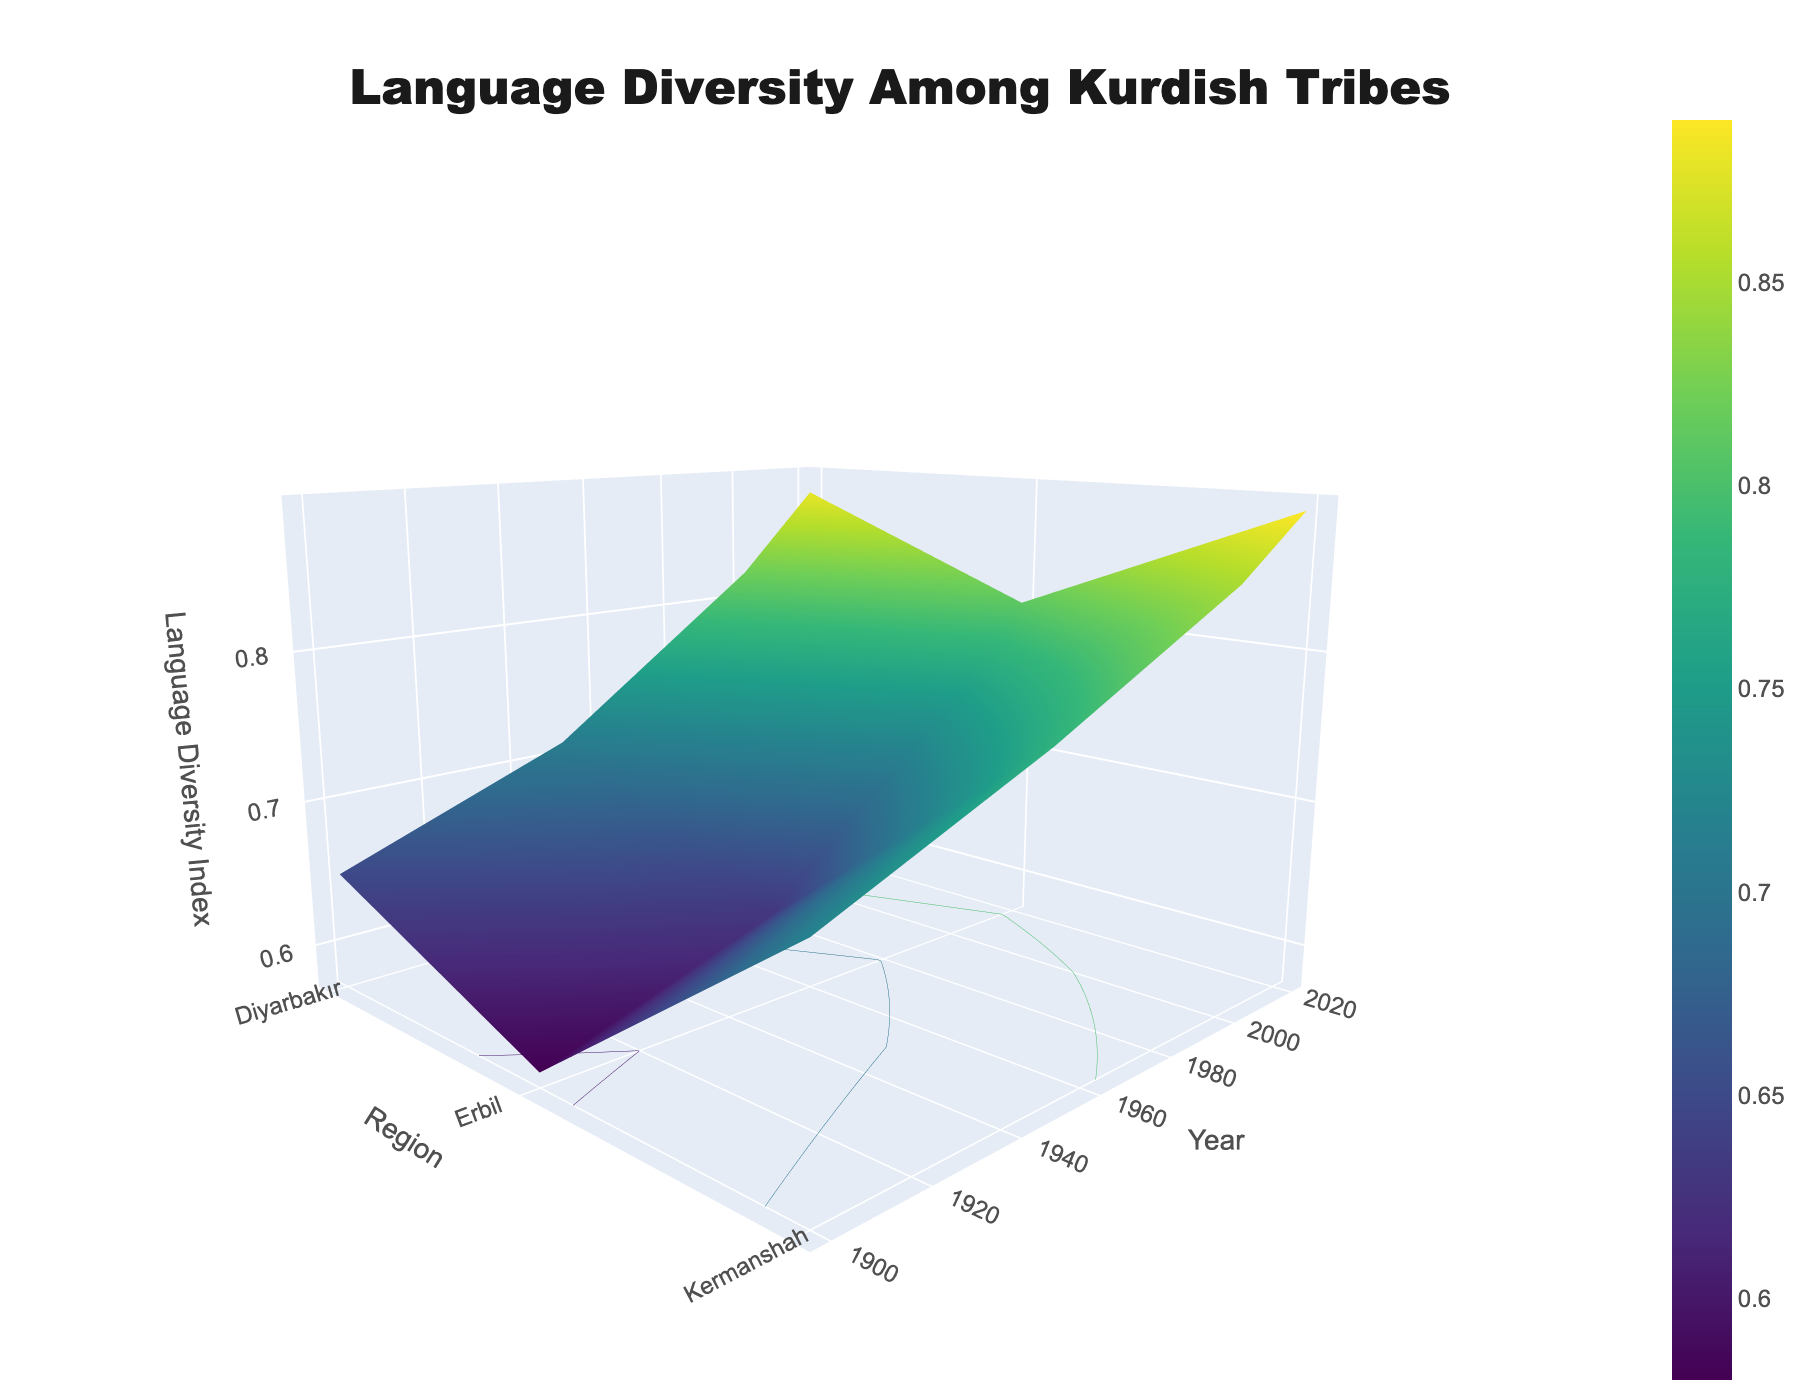What's the title of the figure? The title is located at the top center of the figure. It reads: "Language Diversity Among Kurdish Tribes."
Answer: Language Diversity Among Kurdish Tribes What is the range of the Language Diversity Index over the years in Kermanshah? To find the range, subtract the lowest Language Diversity Index value for Kermanshah from the highest value. The lowest value is 0.72 in 1900 and the highest is 0.89 in 2020. So, the range is 0.89 - 0.72.
Answer: 0.17 Did the Language Diversity Index in Diyarbakır increase or decrease over time? By examining the z-axis values for Diyarbakır from 1900 to 2020, we see that the Language Diversity Index increased year by year. Beginning at 0.65 in 1900 and rising to 0.88 in 2020.
Answer: Increase Which region had the highest Language Diversity Index in 2020? Look at the figure for the 2020 data points across all regions. The highest index is observed at Kermanshah with an index of 0.89.
Answer: Kermanshah Calculate the average Language Diversity Index for Erbil across all the years displayed. Add up the Language Diversity Index values for Erbil over the years and divide by the number of years. (0.58 + 0.63 + 0.75 + 0.81) / 4 = 2.77 / 4 = 0.6925.
Answer: 0.6925 Compare the Language Diversity Index of Diyarbakır and Erbil in 2000. Which one is higher and by how much? The Language Diversity Index for Diyarbakır in 2000 is 0.82, while for Erbil it is 0.75. To find out which one is higher and by how much: 0.82 - 0.75 = 0.07. Diyarbakır's index is higher by 0.07.
Answer: Diyarbakır by 0.07 What is the trend of the surface plot in terms of overall Language Diversity Index from 1900 to 2020? Observing the contours and changes in the z-axis, the Language Diversity Index shows an upward trend for all regions over the years 1900 to 2020.
Answer: Upward trend Which year showed the smallest increase in Language Diversity Index for any region compared to its previous recorded year? Calculate the year-to-year increase for each region and identify the smallest difference. Diyarbakır (1950-1900: 0.71-0.65=0.06), (2000-1950: 0.82-0.71=0.11), (2020-2000: 0.88-0.82=0.06); Erbil (1950-1900: 0.63-0.58=0.05), (2000-1950: 0.75-0.63=0.12), (2020-2000: 0.81-0.75=0.06); Kermanshah (1950-1900: 0.78-0.72=0.06), (2000-1950: 0.85-0.78=0.07), (2020-2000: 0.89-0.85=0.04). The smallest increase is for Kermanshah between 2000 and 2020 which is 0.04.
Answer: 2020 for Kermanshah Identify a region and year where the Language Diversity Index exceeds 0.80. Look at the surface plot for points where the z-axis value (Language Diversity Index) is above 0.80. For instance, Diyarbakır in 2000 (0.82) and 2020 (0.88), Erbil in 2020 (0.81), and Kermanshah from 2000 (0.85) and 2020 (0.89).
Answer: Diyarbakır in 2000 